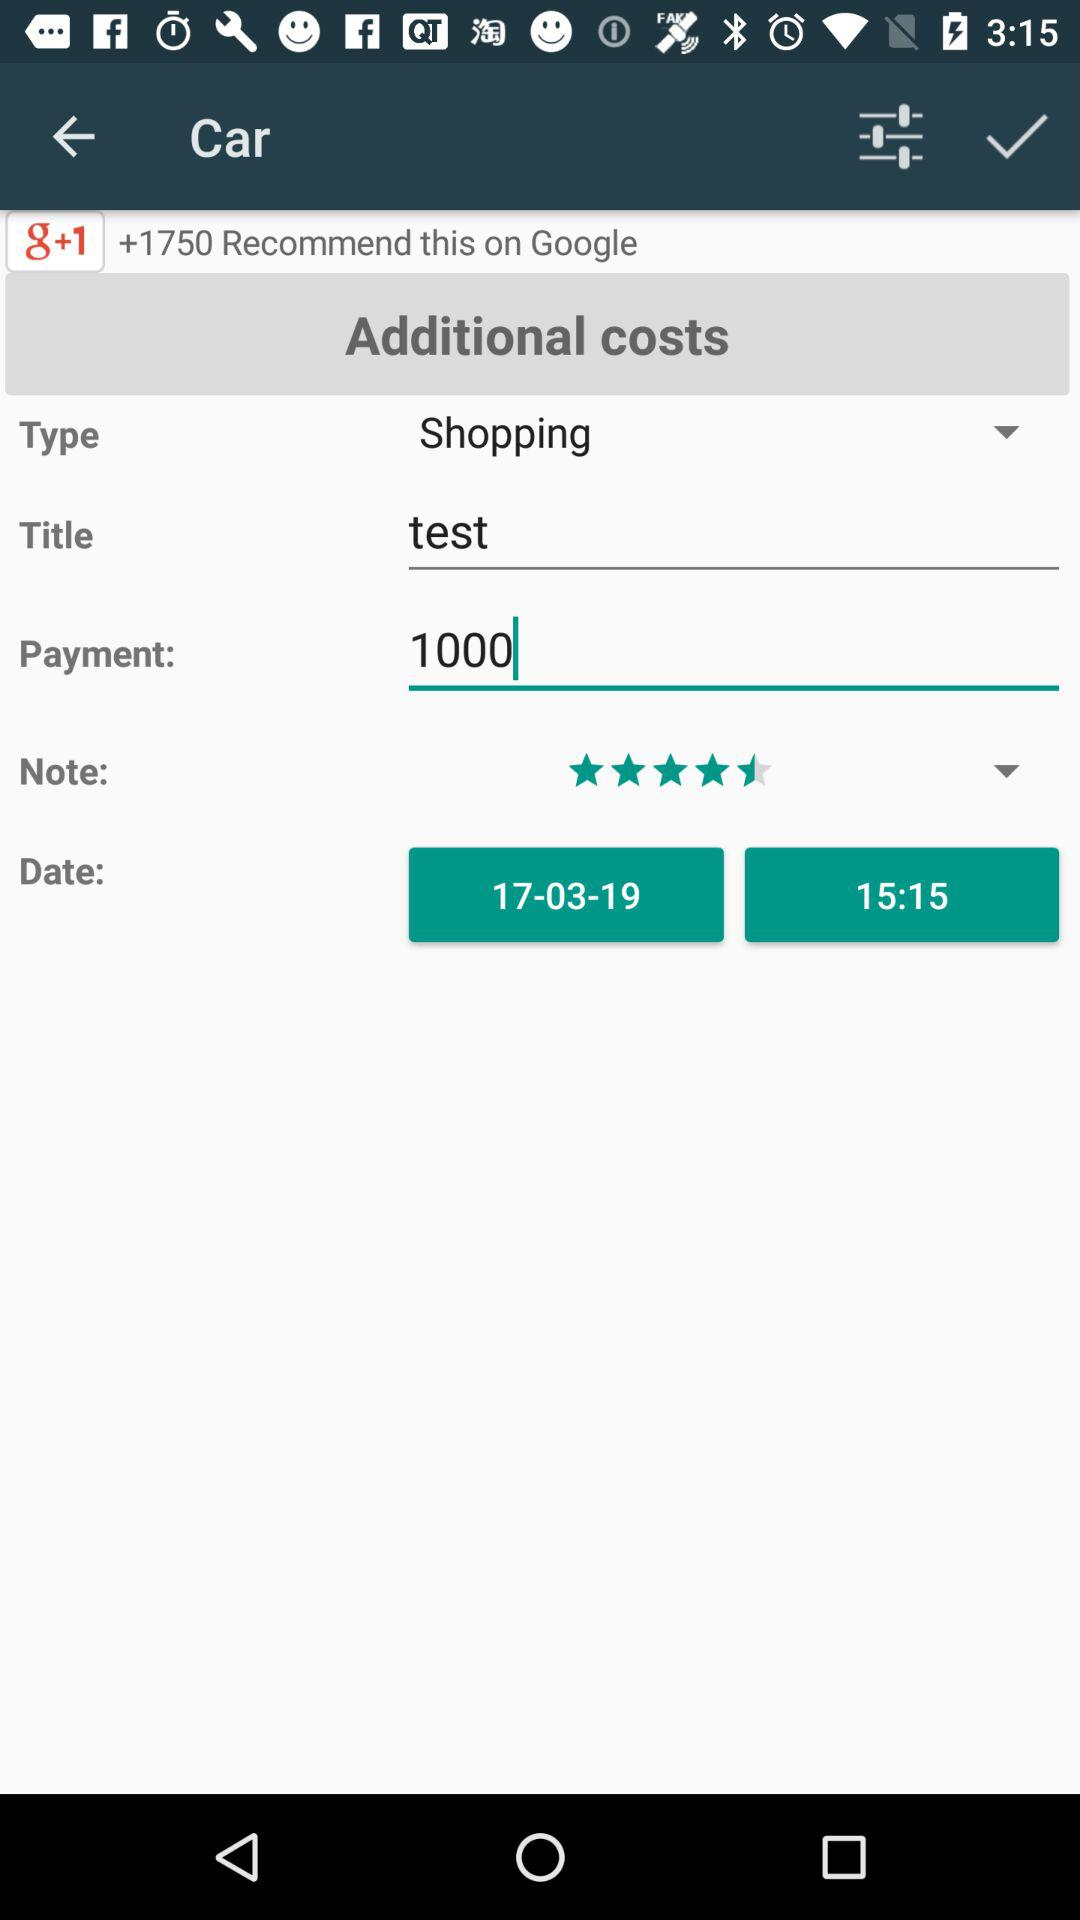What is the selected type? The selected type is "Shopping". 